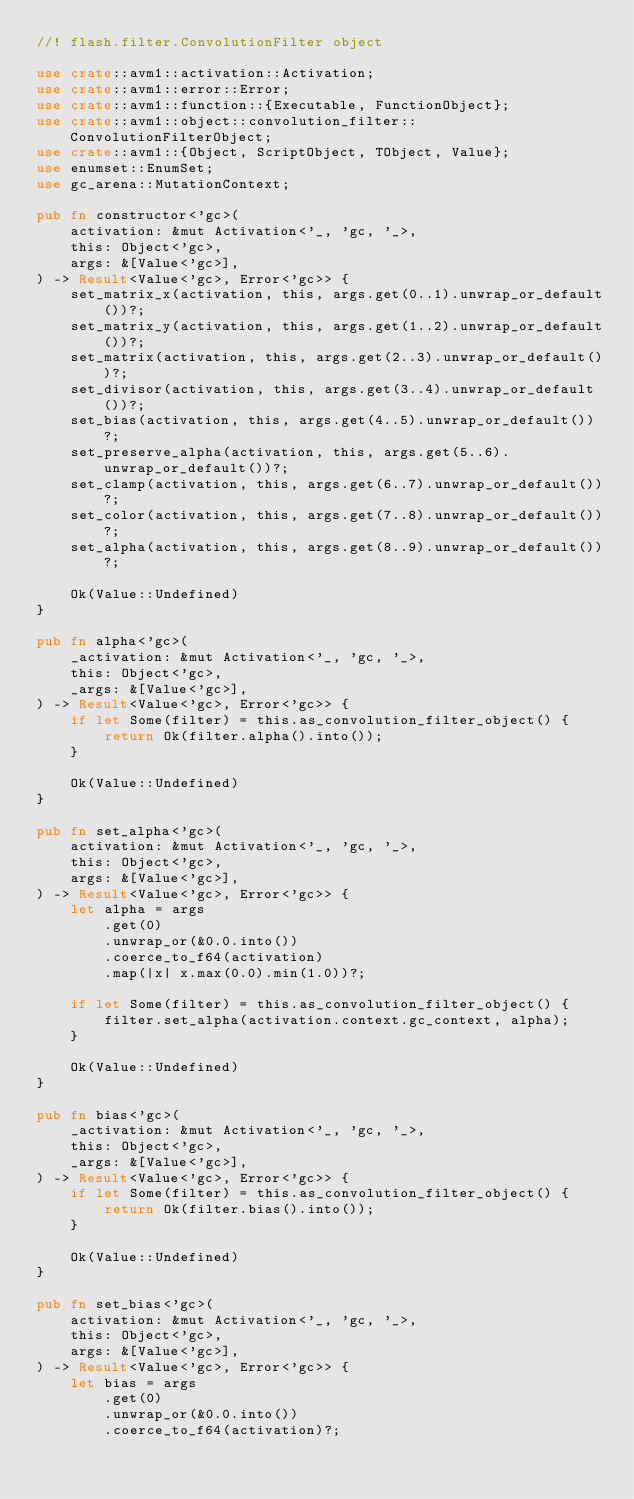Convert code to text. <code><loc_0><loc_0><loc_500><loc_500><_Rust_>//! flash.filter.ConvolutionFilter object

use crate::avm1::activation::Activation;
use crate::avm1::error::Error;
use crate::avm1::function::{Executable, FunctionObject};
use crate::avm1::object::convolution_filter::ConvolutionFilterObject;
use crate::avm1::{Object, ScriptObject, TObject, Value};
use enumset::EnumSet;
use gc_arena::MutationContext;

pub fn constructor<'gc>(
    activation: &mut Activation<'_, 'gc, '_>,
    this: Object<'gc>,
    args: &[Value<'gc>],
) -> Result<Value<'gc>, Error<'gc>> {
    set_matrix_x(activation, this, args.get(0..1).unwrap_or_default())?;
    set_matrix_y(activation, this, args.get(1..2).unwrap_or_default())?;
    set_matrix(activation, this, args.get(2..3).unwrap_or_default())?;
    set_divisor(activation, this, args.get(3..4).unwrap_or_default())?;
    set_bias(activation, this, args.get(4..5).unwrap_or_default())?;
    set_preserve_alpha(activation, this, args.get(5..6).unwrap_or_default())?;
    set_clamp(activation, this, args.get(6..7).unwrap_or_default())?;
    set_color(activation, this, args.get(7..8).unwrap_or_default())?;
    set_alpha(activation, this, args.get(8..9).unwrap_or_default())?;

    Ok(Value::Undefined)
}

pub fn alpha<'gc>(
    _activation: &mut Activation<'_, 'gc, '_>,
    this: Object<'gc>,
    _args: &[Value<'gc>],
) -> Result<Value<'gc>, Error<'gc>> {
    if let Some(filter) = this.as_convolution_filter_object() {
        return Ok(filter.alpha().into());
    }

    Ok(Value::Undefined)
}

pub fn set_alpha<'gc>(
    activation: &mut Activation<'_, 'gc, '_>,
    this: Object<'gc>,
    args: &[Value<'gc>],
) -> Result<Value<'gc>, Error<'gc>> {
    let alpha = args
        .get(0)
        .unwrap_or(&0.0.into())
        .coerce_to_f64(activation)
        .map(|x| x.max(0.0).min(1.0))?;

    if let Some(filter) = this.as_convolution_filter_object() {
        filter.set_alpha(activation.context.gc_context, alpha);
    }

    Ok(Value::Undefined)
}

pub fn bias<'gc>(
    _activation: &mut Activation<'_, 'gc, '_>,
    this: Object<'gc>,
    _args: &[Value<'gc>],
) -> Result<Value<'gc>, Error<'gc>> {
    if let Some(filter) = this.as_convolution_filter_object() {
        return Ok(filter.bias().into());
    }

    Ok(Value::Undefined)
}

pub fn set_bias<'gc>(
    activation: &mut Activation<'_, 'gc, '_>,
    this: Object<'gc>,
    args: &[Value<'gc>],
) -> Result<Value<'gc>, Error<'gc>> {
    let bias = args
        .get(0)
        .unwrap_or(&0.0.into())
        .coerce_to_f64(activation)?;
</code> 